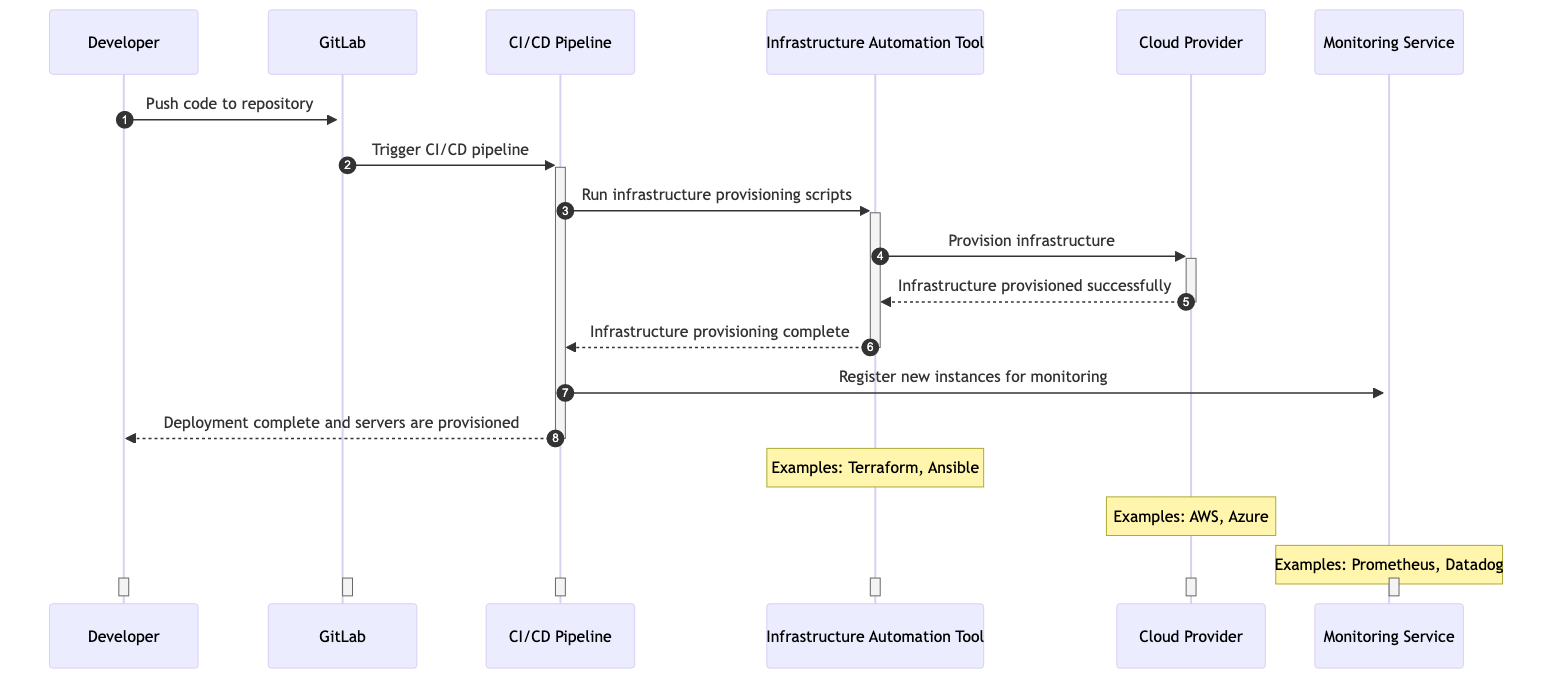What is the first action taken in the sequence? The first action is initiated by the Developer who pushes code to the GitLab repository. This is the starting point in the sequence diagram.
Answer: Push code to repository How many participants are involved in the sequence diagram? The diagram shows six participants: Developer, GitLab, CI/CD Pipeline, Infrastructure Automation Tool, Cloud Provider, and Monitoring Service. Counting them gives a total of six.
Answer: Six Which system is responsible for triggering the CI/CD pipeline? GitLab is responsible for triggering the CI/CD pipeline after receiving the code push from the Developer. This action leads to the next steps in the process.
Answer: GitLab What message does the Infrastructure Automation Tool send to the Cloud Provider? The Infrastructure Automation Tool sends the message to provision infrastructure, specifically to create servers and networks. This request is crucial for the automation process.
Answer: Provision infrastructure What happens after the Infrastructure Automation Tool receives confirmation from the Cloud Provider? After receiving confirmation that infrastructure is provisioned successfully, the Infrastructure Automation Tool sends a message back to the CI/CD Pipeline indicating that the provisioning is complete. This completion allows subsequent actions for monitoring and deployment.
Answer: Infrastructure provisioning complete How does the CI/CD Pipeline interact with the Monitoring Service? The CI/CD Pipeline registers new instances for monitoring after the infrastructure provisioning is complete. This interaction ensures that the new servers are monitored for performance and health.
Answer: Register new instances for monitoring What is the last message sent in the sequence? The last message sent in the sequence is from the CI/CD Pipeline to the Developer, stating that the deployment is complete and the servers are provisioned. This signifies the end of the automated provisioning process within this scenario.
Answer: Deployment complete and servers are provisioned Which two tools are examples of the Infrastructure Automation Tool? The examples mentioned for the Infrastructure Automation Tool are Terraform and Ansible. These tools are commonly used for automation in infrastructure management.
Answer: Terraform, Ansible What type of service is represented by Monitoring Service in the diagram? The Monitoring Service is represented as an external system, providing monitoring solutions for the provisioned infrastructure. This helps ensure the health and performance of the deployed resources.
Answer: External System 